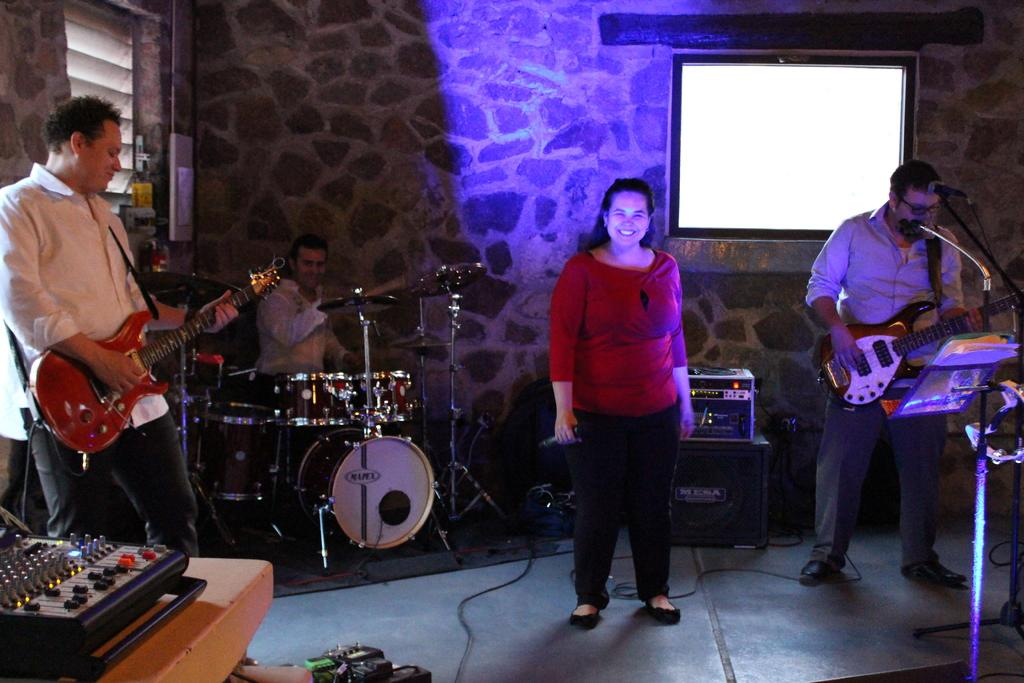What are the people in the image doing? The people in the image are standing and playing music. What are the people holding in the image? The people are holding musical instruments. Can you describe the woman in the middle of the group? The woman in the middle of the group is holding a microphone. What expression does the woman have? The woman is smiling. What type of sack is the woman carrying in the image? There is no sack present in the image; the woman is holding a microphone. What is the profit made from the music performance in the image? There is no information about profit in the image; it only shows people playing music and holding instruments. 